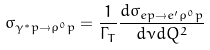Convert formula to latex. <formula><loc_0><loc_0><loc_500><loc_500>\sigma _ { \gamma ^ { * } p \rightarrow \rho ^ { 0 } p } = { \frac { 1 } { \Gamma _ { T } } \frac { d \sigma _ { e p \rightarrow e ^ { \prime } \rho ^ { 0 } p } } { d \nu d Q ^ { 2 } } }</formula> 